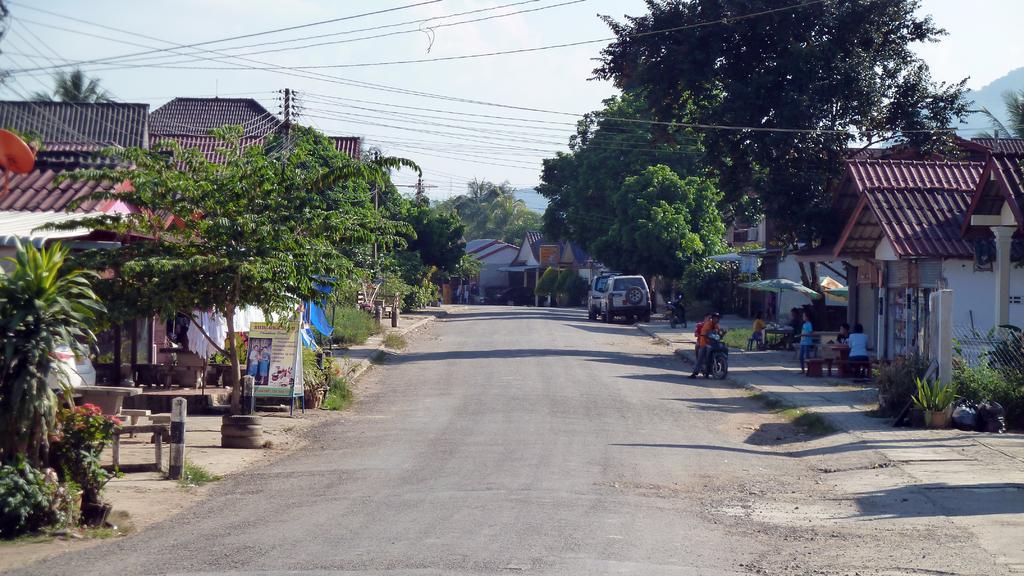Can you describe this image briefly? In this image we can see a road, vehicles, bikes, people, houses, plants, flowers, banners, trees, grass, wires, and few objects. In the background there is sky. 